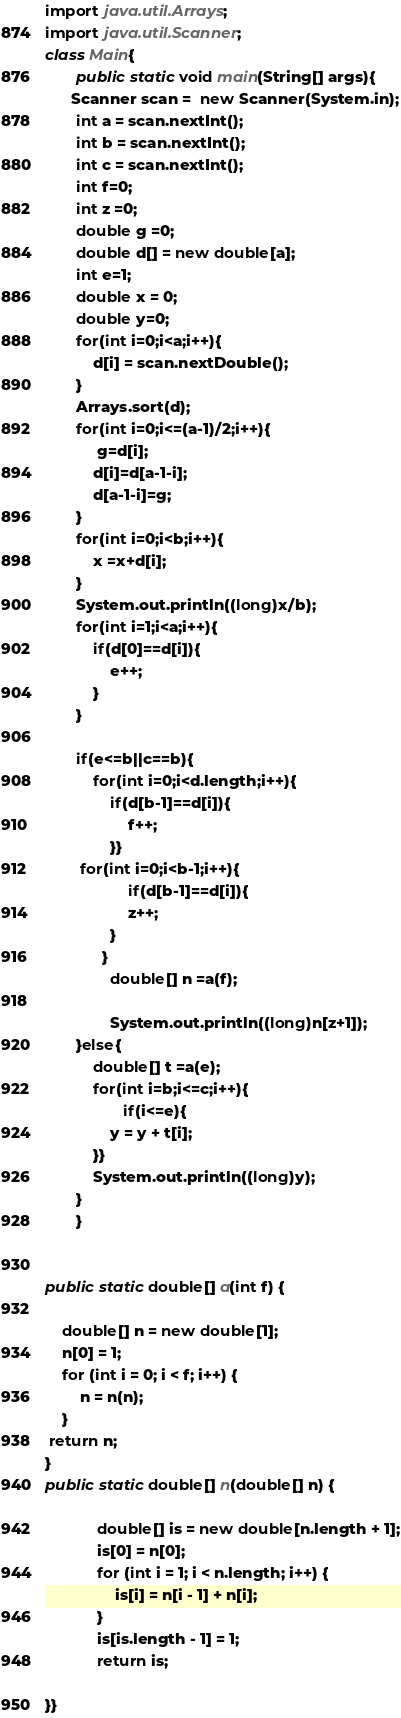<code> <loc_0><loc_0><loc_500><loc_500><_Java_>import java.util.Arrays;
import java.util.Scanner;
class Main{
	   public static void main(String[] args){
	  Scanner scan =  new Scanner(System.in);
	   int a = scan.nextInt();
       int b = scan.nextInt();
       int c = scan.nextInt();
       int f=0;
       int z =0;
       double g =0;
       double d[] = new double[a];
       int e=1;
       double x = 0;
       double y=0;
       for(int i=0;i<a;i++){
    	   d[i] = scan.nextDouble();
       }
       Arrays.sort(d);
       for(int i=0;i<=(a-1)/2;i++){
    	    g=d[i];
    	   d[i]=d[a-1-i];
    	   d[a-1-i]=g;
       }
       for(int i=0;i<b;i++){
    	   x =x+d[i]; 
       }
       System.out.println((long)x/b);
       for(int i=1;i<a;i++){
    	   if(d[0]==d[i]){
    		   e++;
    	   }
       }
       
       if(e<=b||c==b){
    	   for(int i=0;i<d.length;i++){
    		   if(d[b-1]==d[i]){
    			   f++;
    		   }}
        for(int i=0;i<b-1;i++){
    			   if(d[b-1]==d[i]){
    			   z++;
    		   }
    		 }
               double[] n =a(f);
               
               System.out.println((long)n[z+1]);
       }else{
    	   double[] t =a(e);
    	   for(int i=b;i<=c;i++){
                  if(i<=e){
    		   y = y + t[i];
    	   }}
    	   System.out.println((long)y);
       }
	   }
	
 
public static double[] a(int f) {
 
    double[] n = new double[1];
    n[0] = 1;
    for (int i = 0; i < f; i++) {
        n = n(n);
    }
 return n;
}
public static double[] n(double[] n) {
 
	        double[] is = new double[n.length + 1];
	        is[0] = n[0];
	        for (int i = 1; i < n.length; i++) {
	            is[i] = n[i - 1] + n[i];
	        }
	        is[is.length - 1] = 1;
	        return is;
	    
}}</code> 